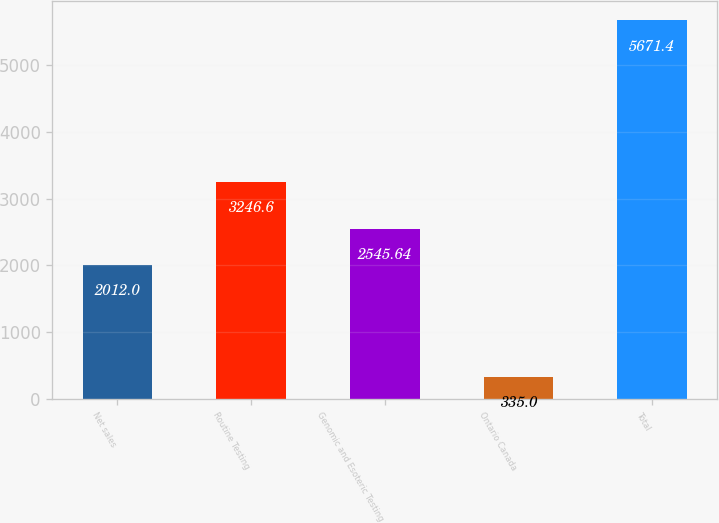<chart> <loc_0><loc_0><loc_500><loc_500><bar_chart><fcel>Net sales<fcel>Routine Testing<fcel>Genomic and Esoteric Testing<fcel>Ontario Canada<fcel>Total<nl><fcel>2012<fcel>3246.6<fcel>2545.64<fcel>335<fcel>5671.4<nl></chart> 